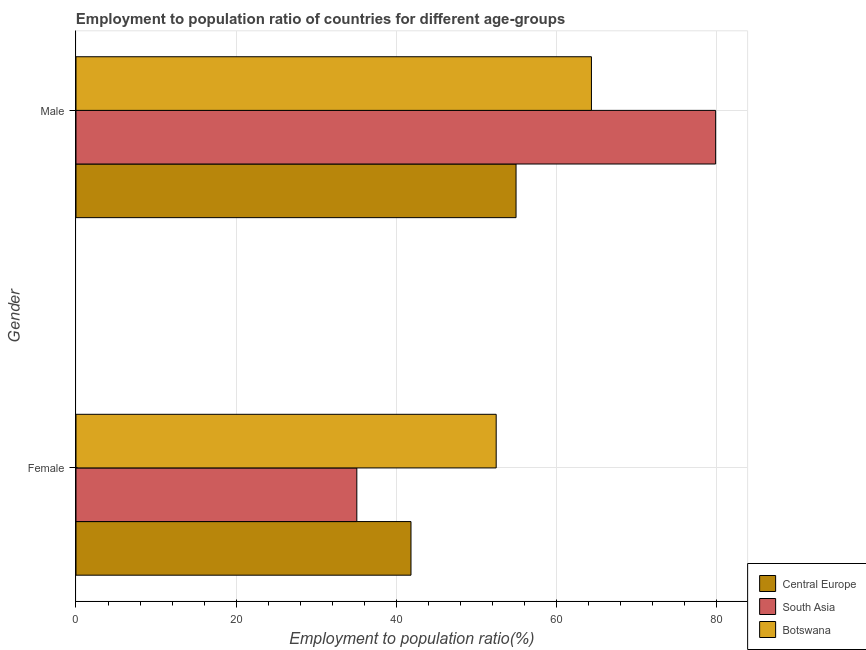How many different coloured bars are there?
Keep it short and to the point. 3. Are the number of bars on each tick of the Y-axis equal?
Offer a terse response. Yes. How many bars are there on the 2nd tick from the top?
Keep it short and to the point. 3. What is the label of the 2nd group of bars from the top?
Keep it short and to the point. Female. What is the employment to population ratio(male) in Botswana?
Ensure brevity in your answer.  64.4. Across all countries, what is the maximum employment to population ratio(female)?
Ensure brevity in your answer.  52.5. Across all countries, what is the minimum employment to population ratio(female)?
Ensure brevity in your answer.  35.09. In which country was the employment to population ratio(female) maximum?
Provide a short and direct response. Botswana. In which country was the employment to population ratio(male) minimum?
Keep it short and to the point. Central Europe. What is the total employment to population ratio(male) in the graph?
Your answer should be very brief. 199.3. What is the difference between the employment to population ratio(female) in South Asia and that in Central Europe?
Give a very brief answer. -6.77. What is the difference between the employment to population ratio(male) in South Asia and the employment to population ratio(female) in Central Europe?
Your response must be concise. 38.06. What is the average employment to population ratio(male) per country?
Keep it short and to the point. 66.43. What is the difference between the employment to population ratio(male) and employment to population ratio(female) in South Asia?
Offer a terse response. 44.83. In how many countries, is the employment to population ratio(female) greater than 16 %?
Offer a terse response. 3. What is the ratio of the employment to population ratio(male) in South Asia to that in Botswana?
Keep it short and to the point. 1.24. What does the 3rd bar from the bottom in Male represents?
Offer a very short reply. Botswana. How many countries are there in the graph?
Make the answer very short. 3. What is the difference between two consecutive major ticks on the X-axis?
Your response must be concise. 20. Does the graph contain any zero values?
Your answer should be very brief. No. What is the title of the graph?
Your answer should be very brief. Employment to population ratio of countries for different age-groups. What is the label or title of the Y-axis?
Offer a very short reply. Gender. What is the Employment to population ratio(%) in Central Europe in Female?
Offer a terse response. 41.85. What is the Employment to population ratio(%) in South Asia in Female?
Keep it short and to the point. 35.09. What is the Employment to population ratio(%) in Botswana in Female?
Make the answer very short. 52.5. What is the Employment to population ratio(%) of Central Europe in Male?
Make the answer very short. 54.98. What is the Employment to population ratio(%) in South Asia in Male?
Keep it short and to the point. 79.92. What is the Employment to population ratio(%) in Botswana in Male?
Offer a very short reply. 64.4. Across all Gender, what is the maximum Employment to population ratio(%) of Central Europe?
Keep it short and to the point. 54.98. Across all Gender, what is the maximum Employment to population ratio(%) of South Asia?
Make the answer very short. 79.92. Across all Gender, what is the maximum Employment to population ratio(%) in Botswana?
Offer a terse response. 64.4. Across all Gender, what is the minimum Employment to population ratio(%) of Central Europe?
Offer a terse response. 41.85. Across all Gender, what is the minimum Employment to population ratio(%) of South Asia?
Offer a terse response. 35.09. Across all Gender, what is the minimum Employment to population ratio(%) of Botswana?
Make the answer very short. 52.5. What is the total Employment to population ratio(%) of Central Europe in the graph?
Your answer should be very brief. 96.84. What is the total Employment to population ratio(%) in South Asia in the graph?
Make the answer very short. 115. What is the total Employment to population ratio(%) in Botswana in the graph?
Offer a very short reply. 116.9. What is the difference between the Employment to population ratio(%) in Central Europe in Female and that in Male?
Your answer should be very brief. -13.13. What is the difference between the Employment to population ratio(%) in South Asia in Female and that in Male?
Provide a succinct answer. -44.83. What is the difference between the Employment to population ratio(%) in Central Europe in Female and the Employment to population ratio(%) in South Asia in Male?
Offer a very short reply. -38.06. What is the difference between the Employment to population ratio(%) in Central Europe in Female and the Employment to population ratio(%) in Botswana in Male?
Your response must be concise. -22.55. What is the difference between the Employment to population ratio(%) in South Asia in Female and the Employment to population ratio(%) in Botswana in Male?
Provide a short and direct response. -29.31. What is the average Employment to population ratio(%) of Central Europe per Gender?
Provide a succinct answer. 48.42. What is the average Employment to population ratio(%) in South Asia per Gender?
Offer a very short reply. 57.5. What is the average Employment to population ratio(%) in Botswana per Gender?
Your answer should be compact. 58.45. What is the difference between the Employment to population ratio(%) of Central Europe and Employment to population ratio(%) of South Asia in Female?
Offer a terse response. 6.77. What is the difference between the Employment to population ratio(%) of Central Europe and Employment to population ratio(%) of Botswana in Female?
Give a very brief answer. -10.65. What is the difference between the Employment to population ratio(%) of South Asia and Employment to population ratio(%) of Botswana in Female?
Your answer should be very brief. -17.41. What is the difference between the Employment to population ratio(%) in Central Europe and Employment to population ratio(%) in South Asia in Male?
Offer a very short reply. -24.94. What is the difference between the Employment to population ratio(%) of Central Europe and Employment to population ratio(%) of Botswana in Male?
Provide a short and direct response. -9.42. What is the difference between the Employment to population ratio(%) in South Asia and Employment to population ratio(%) in Botswana in Male?
Keep it short and to the point. 15.52. What is the ratio of the Employment to population ratio(%) of Central Europe in Female to that in Male?
Ensure brevity in your answer.  0.76. What is the ratio of the Employment to population ratio(%) of South Asia in Female to that in Male?
Provide a short and direct response. 0.44. What is the ratio of the Employment to population ratio(%) in Botswana in Female to that in Male?
Offer a very short reply. 0.82. What is the difference between the highest and the second highest Employment to population ratio(%) in Central Europe?
Ensure brevity in your answer.  13.13. What is the difference between the highest and the second highest Employment to population ratio(%) in South Asia?
Provide a succinct answer. 44.83. What is the difference between the highest and the lowest Employment to population ratio(%) in Central Europe?
Ensure brevity in your answer.  13.13. What is the difference between the highest and the lowest Employment to population ratio(%) of South Asia?
Ensure brevity in your answer.  44.83. 